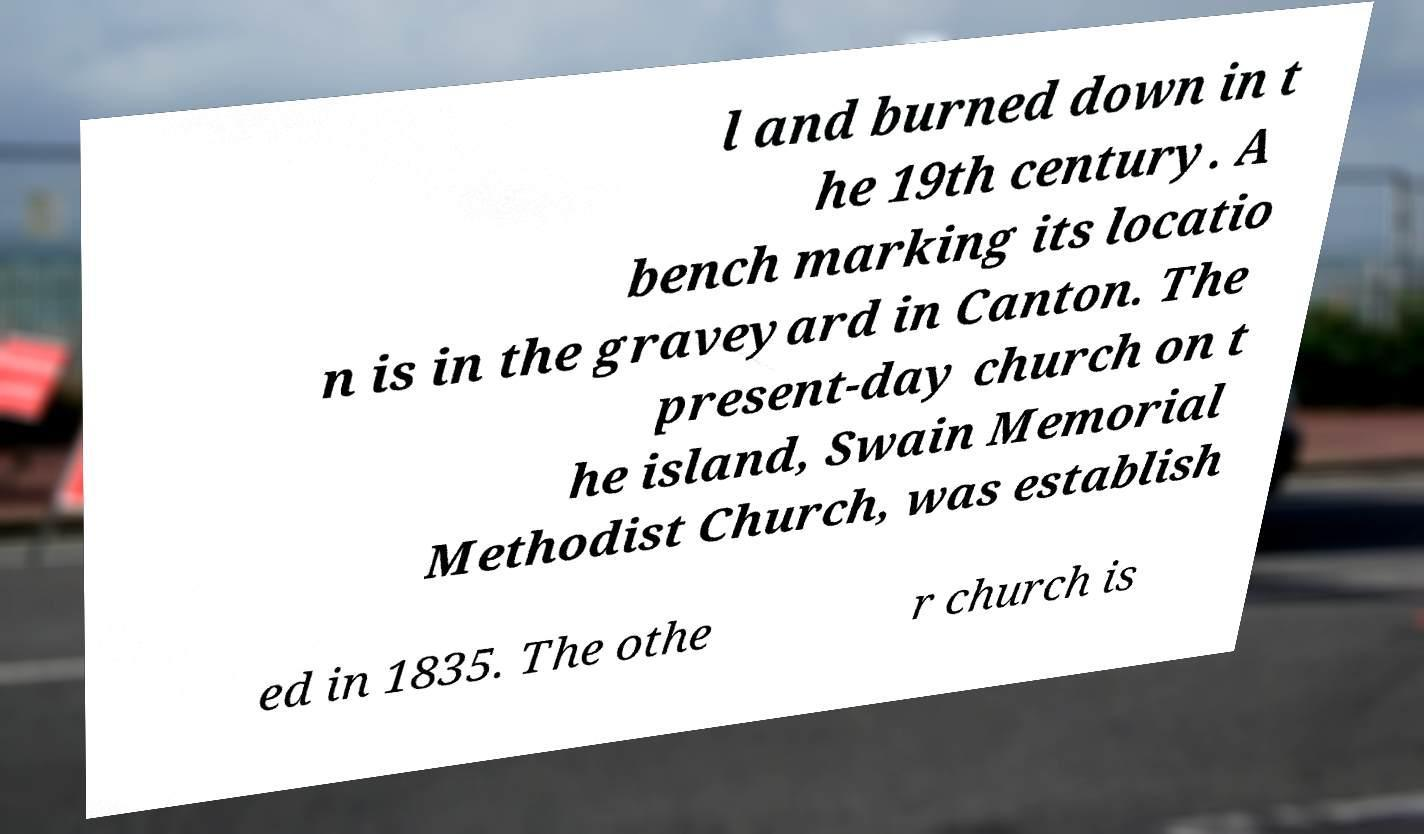There's text embedded in this image that I need extracted. Can you transcribe it verbatim? l and burned down in t he 19th century. A bench marking its locatio n is in the graveyard in Canton. The present-day church on t he island, Swain Memorial Methodist Church, was establish ed in 1835. The othe r church is 